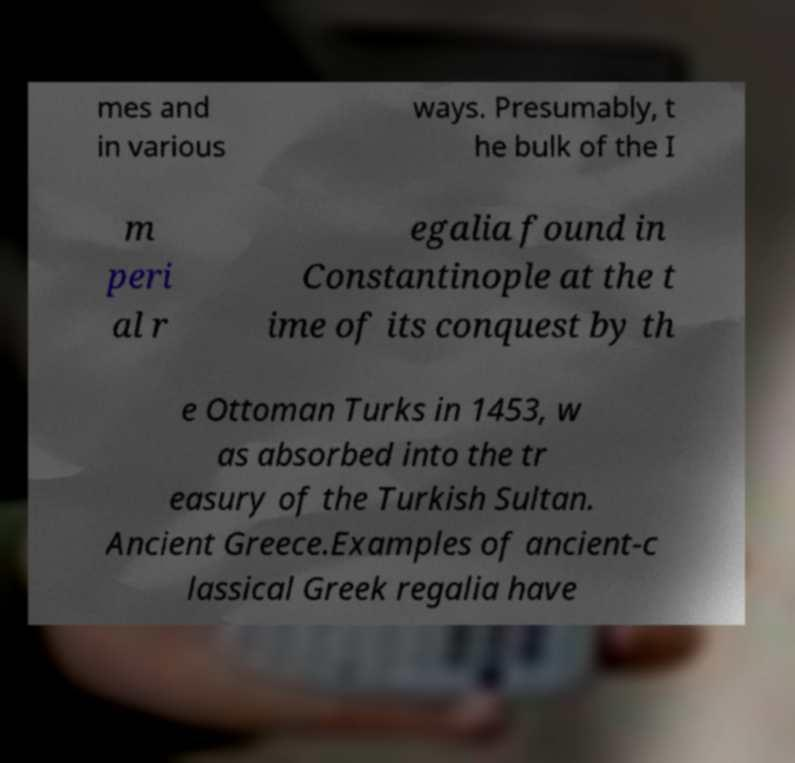Could you assist in decoding the text presented in this image and type it out clearly? mes and in various ways. Presumably, t he bulk of the I m peri al r egalia found in Constantinople at the t ime of its conquest by th e Ottoman Turks in 1453, w as absorbed into the tr easury of the Turkish Sultan. Ancient Greece.Examples of ancient-c lassical Greek regalia have 